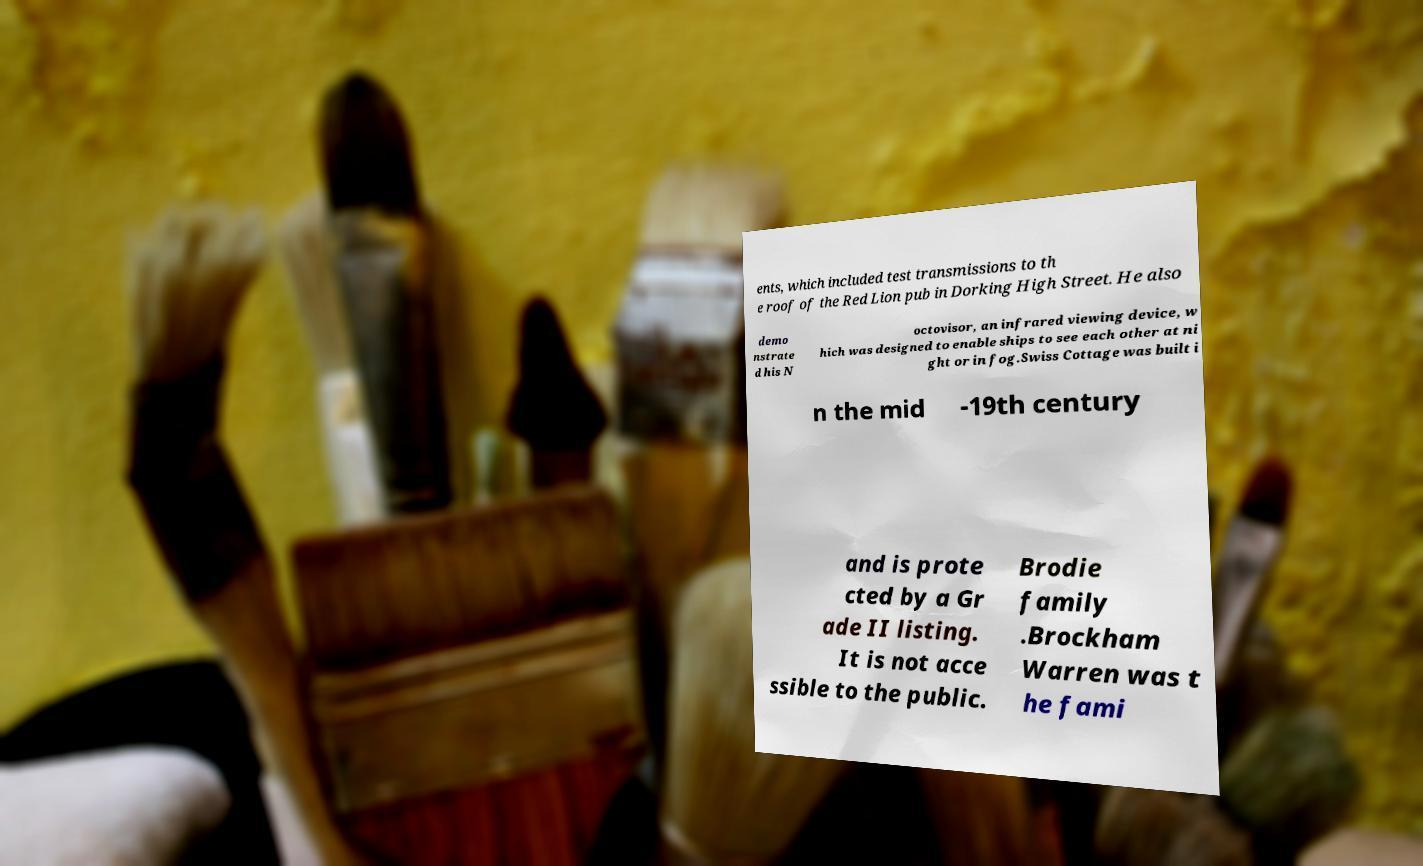I need the written content from this picture converted into text. Can you do that? ents, which included test transmissions to th e roof of the Red Lion pub in Dorking High Street. He also demo nstrate d his N octovisor, an infrared viewing device, w hich was designed to enable ships to see each other at ni ght or in fog.Swiss Cottage was built i n the mid -19th century and is prote cted by a Gr ade II listing. It is not acce ssible to the public. Brodie family .Brockham Warren was t he fami 